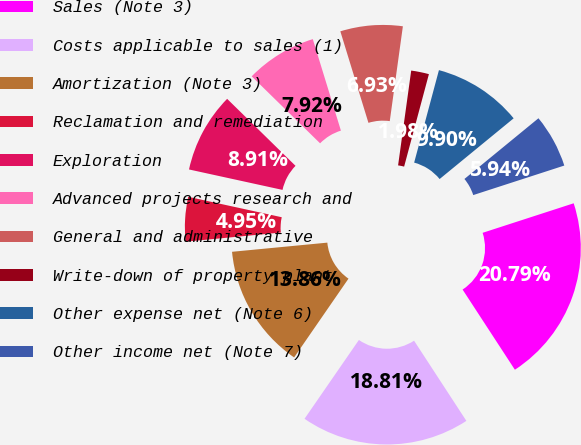Convert chart. <chart><loc_0><loc_0><loc_500><loc_500><pie_chart><fcel>Sales (Note 3)<fcel>Costs applicable to sales (1)<fcel>Amortization (Note 3)<fcel>Reclamation and remediation<fcel>Exploration<fcel>Advanced projects research and<fcel>General and administrative<fcel>Write-down of property plant<fcel>Other expense net (Note 6)<fcel>Other income net (Note 7)<nl><fcel>20.79%<fcel>18.81%<fcel>13.86%<fcel>4.95%<fcel>8.91%<fcel>7.92%<fcel>6.93%<fcel>1.98%<fcel>9.9%<fcel>5.94%<nl></chart> 